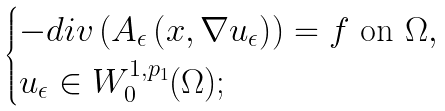Convert formula to latex. <formula><loc_0><loc_0><loc_500><loc_500>\begin{cases} - d i v \left ( A _ { \epsilon } \left ( x , \nabla u _ { \epsilon } \right ) \right ) = f \text { on $\Omega$} , \\ u _ { \epsilon } \in W _ { 0 } ^ { 1 , p _ { 1 } } ( \Omega ) ; \end{cases}</formula> 